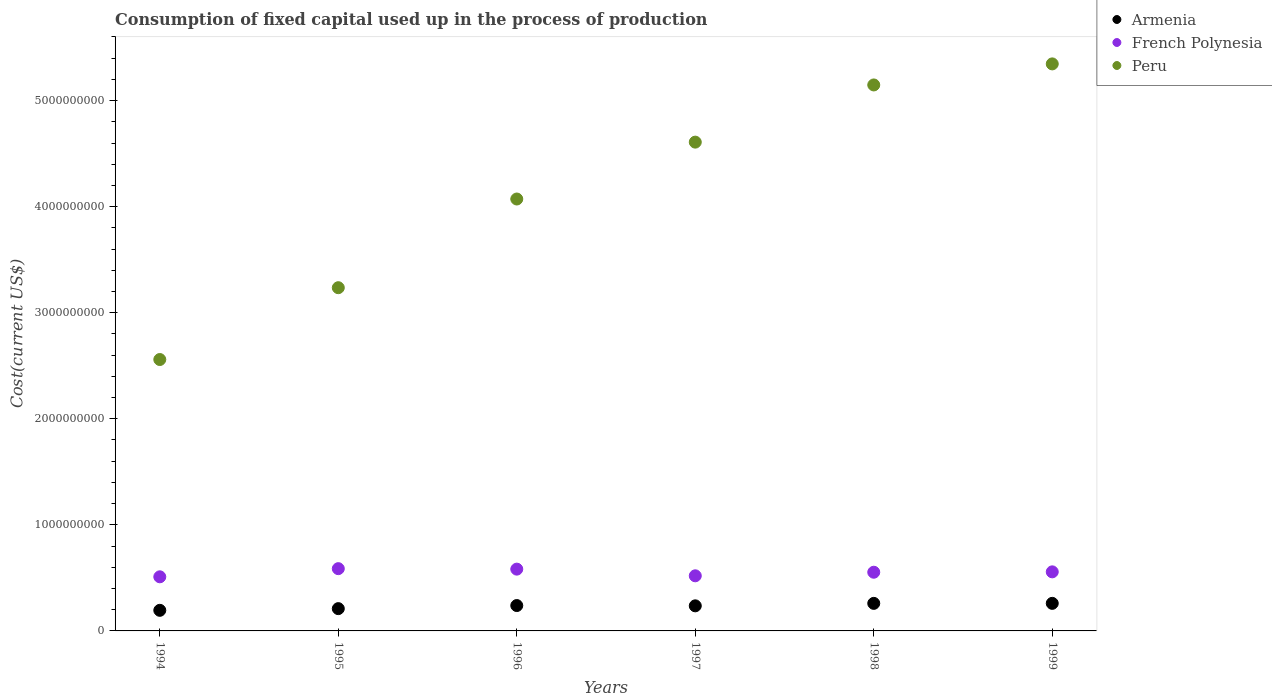How many different coloured dotlines are there?
Your answer should be very brief. 3. Is the number of dotlines equal to the number of legend labels?
Provide a succinct answer. Yes. What is the amount consumed in the process of production in French Polynesia in 1995?
Offer a very short reply. 5.87e+08. Across all years, what is the maximum amount consumed in the process of production in Peru?
Provide a short and direct response. 5.35e+09. Across all years, what is the minimum amount consumed in the process of production in Armenia?
Give a very brief answer. 1.94e+08. In which year was the amount consumed in the process of production in French Polynesia minimum?
Ensure brevity in your answer.  1994. What is the total amount consumed in the process of production in Peru in the graph?
Your answer should be very brief. 2.50e+1. What is the difference between the amount consumed in the process of production in French Polynesia in 1994 and that in 1997?
Your answer should be compact. -9.49e+06. What is the difference between the amount consumed in the process of production in Peru in 1998 and the amount consumed in the process of production in Armenia in 1996?
Offer a very short reply. 4.91e+09. What is the average amount consumed in the process of production in French Polynesia per year?
Provide a succinct answer. 5.52e+08. In the year 1999, what is the difference between the amount consumed in the process of production in Peru and amount consumed in the process of production in French Polynesia?
Make the answer very short. 4.79e+09. In how many years, is the amount consumed in the process of production in French Polynesia greater than 2600000000 US$?
Provide a succinct answer. 0. What is the ratio of the amount consumed in the process of production in Peru in 1996 to that in 1998?
Your answer should be compact. 0.79. What is the difference between the highest and the second highest amount consumed in the process of production in Armenia?
Ensure brevity in your answer.  1.33e+05. What is the difference between the highest and the lowest amount consumed in the process of production in Peru?
Keep it short and to the point. 2.79e+09. Is the amount consumed in the process of production in Peru strictly less than the amount consumed in the process of production in French Polynesia over the years?
Give a very brief answer. No. How many dotlines are there?
Your answer should be very brief. 3. Does the graph contain any zero values?
Your answer should be very brief. No. How many legend labels are there?
Keep it short and to the point. 3. How are the legend labels stacked?
Make the answer very short. Vertical. What is the title of the graph?
Offer a terse response. Consumption of fixed capital used up in the process of production. What is the label or title of the X-axis?
Provide a short and direct response. Years. What is the label or title of the Y-axis?
Your response must be concise. Cost(current US$). What is the Cost(current US$) of Armenia in 1994?
Make the answer very short. 1.94e+08. What is the Cost(current US$) of French Polynesia in 1994?
Your answer should be very brief. 5.10e+08. What is the Cost(current US$) of Peru in 1994?
Make the answer very short. 2.56e+09. What is the Cost(current US$) of Armenia in 1995?
Offer a very short reply. 2.10e+08. What is the Cost(current US$) of French Polynesia in 1995?
Provide a succinct answer. 5.87e+08. What is the Cost(current US$) in Peru in 1995?
Provide a succinct answer. 3.24e+09. What is the Cost(current US$) of Armenia in 1996?
Make the answer very short. 2.39e+08. What is the Cost(current US$) of French Polynesia in 1996?
Offer a very short reply. 5.83e+08. What is the Cost(current US$) in Peru in 1996?
Your answer should be very brief. 4.07e+09. What is the Cost(current US$) in Armenia in 1997?
Offer a very short reply. 2.37e+08. What is the Cost(current US$) of French Polynesia in 1997?
Provide a succinct answer. 5.20e+08. What is the Cost(current US$) of Peru in 1997?
Give a very brief answer. 4.61e+09. What is the Cost(current US$) of Armenia in 1998?
Provide a short and direct response. 2.60e+08. What is the Cost(current US$) in French Polynesia in 1998?
Give a very brief answer. 5.53e+08. What is the Cost(current US$) in Peru in 1998?
Keep it short and to the point. 5.15e+09. What is the Cost(current US$) in Armenia in 1999?
Keep it short and to the point. 2.60e+08. What is the Cost(current US$) in French Polynesia in 1999?
Your answer should be compact. 5.57e+08. What is the Cost(current US$) in Peru in 1999?
Your response must be concise. 5.35e+09. Across all years, what is the maximum Cost(current US$) in Armenia?
Provide a succinct answer. 2.60e+08. Across all years, what is the maximum Cost(current US$) of French Polynesia?
Make the answer very short. 5.87e+08. Across all years, what is the maximum Cost(current US$) in Peru?
Offer a terse response. 5.35e+09. Across all years, what is the minimum Cost(current US$) of Armenia?
Keep it short and to the point. 1.94e+08. Across all years, what is the minimum Cost(current US$) of French Polynesia?
Your response must be concise. 5.10e+08. Across all years, what is the minimum Cost(current US$) of Peru?
Provide a succinct answer. 2.56e+09. What is the total Cost(current US$) of Armenia in the graph?
Your answer should be very brief. 1.40e+09. What is the total Cost(current US$) in French Polynesia in the graph?
Your answer should be very brief. 3.31e+09. What is the total Cost(current US$) in Peru in the graph?
Your response must be concise. 2.50e+1. What is the difference between the Cost(current US$) of Armenia in 1994 and that in 1995?
Offer a very short reply. -1.60e+07. What is the difference between the Cost(current US$) of French Polynesia in 1994 and that in 1995?
Keep it short and to the point. -7.68e+07. What is the difference between the Cost(current US$) in Peru in 1994 and that in 1995?
Provide a short and direct response. -6.77e+08. What is the difference between the Cost(current US$) in Armenia in 1994 and that in 1996?
Give a very brief answer. -4.50e+07. What is the difference between the Cost(current US$) in French Polynesia in 1994 and that in 1996?
Offer a terse response. -7.23e+07. What is the difference between the Cost(current US$) in Peru in 1994 and that in 1996?
Your answer should be compact. -1.51e+09. What is the difference between the Cost(current US$) of Armenia in 1994 and that in 1997?
Offer a terse response. -4.24e+07. What is the difference between the Cost(current US$) in French Polynesia in 1994 and that in 1997?
Keep it short and to the point. -9.49e+06. What is the difference between the Cost(current US$) of Peru in 1994 and that in 1997?
Your answer should be very brief. -2.05e+09. What is the difference between the Cost(current US$) in Armenia in 1994 and that in 1998?
Offer a very short reply. -6.56e+07. What is the difference between the Cost(current US$) in French Polynesia in 1994 and that in 1998?
Provide a succinct answer. -4.31e+07. What is the difference between the Cost(current US$) in Peru in 1994 and that in 1998?
Provide a succinct answer. -2.59e+09. What is the difference between the Cost(current US$) in Armenia in 1994 and that in 1999?
Provide a succinct answer. -6.57e+07. What is the difference between the Cost(current US$) of French Polynesia in 1994 and that in 1999?
Give a very brief answer. -4.67e+07. What is the difference between the Cost(current US$) in Peru in 1994 and that in 1999?
Provide a short and direct response. -2.79e+09. What is the difference between the Cost(current US$) in Armenia in 1995 and that in 1996?
Give a very brief answer. -2.91e+07. What is the difference between the Cost(current US$) in French Polynesia in 1995 and that in 1996?
Give a very brief answer. 4.51e+06. What is the difference between the Cost(current US$) of Peru in 1995 and that in 1996?
Offer a terse response. -8.36e+08. What is the difference between the Cost(current US$) of Armenia in 1995 and that in 1997?
Give a very brief answer. -2.64e+07. What is the difference between the Cost(current US$) in French Polynesia in 1995 and that in 1997?
Your answer should be compact. 6.74e+07. What is the difference between the Cost(current US$) of Peru in 1995 and that in 1997?
Provide a short and direct response. -1.37e+09. What is the difference between the Cost(current US$) of Armenia in 1995 and that in 1998?
Ensure brevity in your answer.  -4.96e+07. What is the difference between the Cost(current US$) of French Polynesia in 1995 and that in 1998?
Provide a succinct answer. 3.37e+07. What is the difference between the Cost(current US$) in Peru in 1995 and that in 1998?
Your response must be concise. -1.91e+09. What is the difference between the Cost(current US$) in Armenia in 1995 and that in 1999?
Offer a terse response. -4.98e+07. What is the difference between the Cost(current US$) of French Polynesia in 1995 and that in 1999?
Provide a succinct answer. 3.01e+07. What is the difference between the Cost(current US$) in Peru in 1995 and that in 1999?
Ensure brevity in your answer.  -2.11e+09. What is the difference between the Cost(current US$) of Armenia in 1996 and that in 1997?
Offer a very short reply. 2.68e+06. What is the difference between the Cost(current US$) in French Polynesia in 1996 and that in 1997?
Your answer should be very brief. 6.28e+07. What is the difference between the Cost(current US$) of Peru in 1996 and that in 1997?
Your response must be concise. -5.36e+08. What is the difference between the Cost(current US$) of Armenia in 1996 and that in 1998?
Offer a terse response. -2.05e+07. What is the difference between the Cost(current US$) in French Polynesia in 1996 and that in 1998?
Offer a very short reply. 2.92e+07. What is the difference between the Cost(current US$) of Peru in 1996 and that in 1998?
Your response must be concise. -1.08e+09. What is the difference between the Cost(current US$) of Armenia in 1996 and that in 1999?
Your answer should be very brief. -2.07e+07. What is the difference between the Cost(current US$) in French Polynesia in 1996 and that in 1999?
Give a very brief answer. 2.56e+07. What is the difference between the Cost(current US$) of Peru in 1996 and that in 1999?
Give a very brief answer. -1.27e+09. What is the difference between the Cost(current US$) of Armenia in 1997 and that in 1998?
Your response must be concise. -2.32e+07. What is the difference between the Cost(current US$) in French Polynesia in 1997 and that in 1998?
Your answer should be very brief. -3.37e+07. What is the difference between the Cost(current US$) of Peru in 1997 and that in 1998?
Give a very brief answer. -5.39e+08. What is the difference between the Cost(current US$) of Armenia in 1997 and that in 1999?
Provide a short and direct response. -2.34e+07. What is the difference between the Cost(current US$) in French Polynesia in 1997 and that in 1999?
Ensure brevity in your answer.  -3.72e+07. What is the difference between the Cost(current US$) in Peru in 1997 and that in 1999?
Your answer should be compact. -7.38e+08. What is the difference between the Cost(current US$) in Armenia in 1998 and that in 1999?
Ensure brevity in your answer.  -1.33e+05. What is the difference between the Cost(current US$) in French Polynesia in 1998 and that in 1999?
Ensure brevity in your answer.  -3.55e+06. What is the difference between the Cost(current US$) in Peru in 1998 and that in 1999?
Keep it short and to the point. -1.98e+08. What is the difference between the Cost(current US$) of Armenia in 1994 and the Cost(current US$) of French Polynesia in 1995?
Make the answer very short. -3.93e+08. What is the difference between the Cost(current US$) in Armenia in 1994 and the Cost(current US$) in Peru in 1995?
Offer a very short reply. -3.04e+09. What is the difference between the Cost(current US$) of French Polynesia in 1994 and the Cost(current US$) of Peru in 1995?
Your answer should be compact. -2.73e+09. What is the difference between the Cost(current US$) of Armenia in 1994 and the Cost(current US$) of French Polynesia in 1996?
Offer a very short reply. -3.88e+08. What is the difference between the Cost(current US$) of Armenia in 1994 and the Cost(current US$) of Peru in 1996?
Give a very brief answer. -3.88e+09. What is the difference between the Cost(current US$) in French Polynesia in 1994 and the Cost(current US$) in Peru in 1996?
Make the answer very short. -3.56e+09. What is the difference between the Cost(current US$) of Armenia in 1994 and the Cost(current US$) of French Polynesia in 1997?
Offer a very short reply. -3.25e+08. What is the difference between the Cost(current US$) in Armenia in 1994 and the Cost(current US$) in Peru in 1997?
Provide a succinct answer. -4.41e+09. What is the difference between the Cost(current US$) of French Polynesia in 1994 and the Cost(current US$) of Peru in 1997?
Your answer should be very brief. -4.10e+09. What is the difference between the Cost(current US$) of Armenia in 1994 and the Cost(current US$) of French Polynesia in 1998?
Provide a succinct answer. -3.59e+08. What is the difference between the Cost(current US$) in Armenia in 1994 and the Cost(current US$) in Peru in 1998?
Keep it short and to the point. -4.95e+09. What is the difference between the Cost(current US$) in French Polynesia in 1994 and the Cost(current US$) in Peru in 1998?
Offer a terse response. -4.64e+09. What is the difference between the Cost(current US$) in Armenia in 1994 and the Cost(current US$) in French Polynesia in 1999?
Keep it short and to the point. -3.63e+08. What is the difference between the Cost(current US$) of Armenia in 1994 and the Cost(current US$) of Peru in 1999?
Give a very brief answer. -5.15e+09. What is the difference between the Cost(current US$) of French Polynesia in 1994 and the Cost(current US$) of Peru in 1999?
Your response must be concise. -4.84e+09. What is the difference between the Cost(current US$) in Armenia in 1995 and the Cost(current US$) in French Polynesia in 1996?
Provide a short and direct response. -3.72e+08. What is the difference between the Cost(current US$) of Armenia in 1995 and the Cost(current US$) of Peru in 1996?
Ensure brevity in your answer.  -3.86e+09. What is the difference between the Cost(current US$) in French Polynesia in 1995 and the Cost(current US$) in Peru in 1996?
Your answer should be very brief. -3.48e+09. What is the difference between the Cost(current US$) in Armenia in 1995 and the Cost(current US$) in French Polynesia in 1997?
Make the answer very short. -3.10e+08. What is the difference between the Cost(current US$) of Armenia in 1995 and the Cost(current US$) of Peru in 1997?
Provide a short and direct response. -4.40e+09. What is the difference between the Cost(current US$) of French Polynesia in 1995 and the Cost(current US$) of Peru in 1997?
Keep it short and to the point. -4.02e+09. What is the difference between the Cost(current US$) in Armenia in 1995 and the Cost(current US$) in French Polynesia in 1998?
Ensure brevity in your answer.  -3.43e+08. What is the difference between the Cost(current US$) of Armenia in 1995 and the Cost(current US$) of Peru in 1998?
Make the answer very short. -4.94e+09. What is the difference between the Cost(current US$) of French Polynesia in 1995 and the Cost(current US$) of Peru in 1998?
Provide a short and direct response. -4.56e+09. What is the difference between the Cost(current US$) in Armenia in 1995 and the Cost(current US$) in French Polynesia in 1999?
Provide a succinct answer. -3.47e+08. What is the difference between the Cost(current US$) of Armenia in 1995 and the Cost(current US$) of Peru in 1999?
Provide a short and direct response. -5.14e+09. What is the difference between the Cost(current US$) in French Polynesia in 1995 and the Cost(current US$) in Peru in 1999?
Keep it short and to the point. -4.76e+09. What is the difference between the Cost(current US$) of Armenia in 1996 and the Cost(current US$) of French Polynesia in 1997?
Make the answer very short. -2.80e+08. What is the difference between the Cost(current US$) in Armenia in 1996 and the Cost(current US$) in Peru in 1997?
Offer a terse response. -4.37e+09. What is the difference between the Cost(current US$) of French Polynesia in 1996 and the Cost(current US$) of Peru in 1997?
Offer a terse response. -4.03e+09. What is the difference between the Cost(current US$) of Armenia in 1996 and the Cost(current US$) of French Polynesia in 1998?
Your response must be concise. -3.14e+08. What is the difference between the Cost(current US$) of Armenia in 1996 and the Cost(current US$) of Peru in 1998?
Provide a short and direct response. -4.91e+09. What is the difference between the Cost(current US$) in French Polynesia in 1996 and the Cost(current US$) in Peru in 1998?
Give a very brief answer. -4.56e+09. What is the difference between the Cost(current US$) in Armenia in 1996 and the Cost(current US$) in French Polynesia in 1999?
Your response must be concise. -3.18e+08. What is the difference between the Cost(current US$) in Armenia in 1996 and the Cost(current US$) in Peru in 1999?
Provide a short and direct response. -5.11e+09. What is the difference between the Cost(current US$) in French Polynesia in 1996 and the Cost(current US$) in Peru in 1999?
Provide a succinct answer. -4.76e+09. What is the difference between the Cost(current US$) in Armenia in 1997 and the Cost(current US$) in French Polynesia in 1998?
Ensure brevity in your answer.  -3.17e+08. What is the difference between the Cost(current US$) in Armenia in 1997 and the Cost(current US$) in Peru in 1998?
Offer a very short reply. -4.91e+09. What is the difference between the Cost(current US$) of French Polynesia in 1997 and the Cost(current US$) of Peru in 1998?
Offer a terse response. -4.63e+09. What is the difference between the Cost(current US$) of Armenia in 1997 and the Cost(current US$) of French Polynesia in 1999?
Ensure brevity in your answer.  -3.20e+08. What is the difference between the Cost(current US$) in Armenia in 1997 and the Cost(current US$) in Peru in 1999?
Offer a very short reply. -5.11e+09. What is the difference between the Cost(current US$) of French Polynesia in 1997 and the Cost(current US$) of Peru in 1999?
Provide a short and direct response. -4.83e+09. What is the difference between the Cost(current US$) in Armenia in 1998 and the Cost(current US$) in French Polynesia in 1999?
Offer a very short reply. -2.97e+08. What is the difference between the Cost(current US$) in Armenia in 1998 and the Cost(current US$) in Peru in 1999?
Ensure brevity in your answer.  -5.09e+09. What is the difference between the Cost(current US$) in French Polynesia in 1998 and the Cost(current US$) in Peru in 1999?
Your response must be concise. -4.79e+09. What is the average Cost(current US$) of Armenia per year?
Provide a succinct answer. 2.33e+08. What is the average Cost(current US$) in French Polynesia per year?
Your answer should be compact. 5.52e+08. What is the average Cost(current US$) of Peru per year?
Ensure brevity in your answer.  4.16e+09. In the year 1994, what is the difference between the Cost(current US$) of Armenia and Cost(current US$) of French Polynesia?
Give a very brief answer. -3.16e+08. In the year 1994, what is the difference between the Cost(current US$) of Armenia and Cost(current US$) of Peru?
Ensure brevity in your answer.  -2.36e+09. In the year 1994, what is the difference between the Cost(current US$) in French Polynesia and Cost(current US$) in Peru?
Your answer should be very brief. -2.05e+09. In the year 1995, what is the difference between the Cost(current US$) in Armenia and Cost(current US$) in French Polynesia?
Ensure brevity in your answer.  -3.77e+08. In the year 1995, what is the difference between the Cost(current US$) in Armenia and Cost(current US$) in Peru?
Provide a short and direct response. -3.03e+09. In the year 1995, what is the difference between the Cost(current US$) of French Polynesia and Cost(current US$) of Peru?
Ensure brevity in your answer.  -2.65e+09. In the year 1996, what is the difference between the Cost(current US$) of Armenia and Cost(current US$) of French Polynesia?
Give a very brief answer. -3.43e+08. In the year 1996, what is the difference between the Cost(current US$) in Armenia and Cost(current US$) in Peru?
Provide a short and direct response. -3.83e+09. In the year 1996, what is the difference between the Cost(current US$) in French Polynesia and Cost(current US$) in Peru?
Offer a terse response. -3.49e+09. In the year 1997, what is the difference between the Cost(current US$) of Armenia and Cost(current US$) of French Polynesia?
Your answer should be very brief. -2.83e+08. In the year 1997, what is the difference between the Cost(current US$) in Armenia and Cost(current US$) in Peru?
Your answer should be very brief. -4.37e+09. In the year 1997, what is the difference between the Cost(current US$) of French Polynesia and Cost(current US$) of Peru?
Offer a terse response. -4.09e+09. In the year 1998, what is the difference between the Cost(current US$) in Armenia and Cost(current US$) in French Polynesia?
Give a very brief answer. -2.94e+08. In the year 1998, what is the difference between the Cost(current US$) in Armenia and Cost(current US$) in Peru?
Give a very brief answer. -4.89e+09. In the year 1998, what is the difference between the Cost(current US$) of French Polynesia and Cost(current US$) of Peru?
Give a very brief answer. -4.59e+09. In the year 1999, what is the difference between the Cost(current US$) of Armenia and Cost(current US$) of French Polynesia?
Your answer should be compact. -2.97e+08. In the year 1999, what is the difference between the Cost(current US$) in Armenia and Cost(current US$) in Peru?
Give a very brief answer. -5.09e+09. In the year 1999, what is the difference between the Cost(current US$) in French Polynesia and Cost(current US$) in Peru?
Provide a succinct answer. -4.79e+09. What is the ratio of the Cost(current US$) of Armenia in 1994 to that in 1995?
Keep it short and to the point. 0.92. What is the ratio of the Cost(current US$) of French Polynesia in 1994 to that in 1995?
Ensure brevity in your answer.  0.87. What is the ratio of the Cost(current US$) in Peru in 1994 to that in 1995?
Provide a succinct answer. 0.79. What is the ratio of the Cost(current US$) of Armenia in 1994 to that in 1996?
Make the answer very short. 0.81. What is the ratio of the Cost(current US$) of French Polynesia in 1994 to that in 1996?
Your answer should be very brief. 0.88. What is the ratio of the Cost(current US$) of Peru in 1994 to that in 1996?
Your response must be concise. 0.63. What is the ratio of the Cost(current US$) of Armenia in 1994 to that in 1997?
Give a very brief answer. 0.82. What is the ratio of the Cost(current US$) of French Polynesia in 1994 to that in 1997?
Ensure brevity in your answer.  0.98. What is the ratio of the Cost(current US$) of Peru in 1994 to that in 1997?
Give a very brief answer. 0.56. What is the ratio of the Cost(current US$) in Armenia in 1994 to that in 1998?
Provide a succinct answer. 0.75. What is the ratio of the Cost(current US$) in French Polynesia in 1994 to that in 1998?
Make the answer very short. 0.92. What is the ratio of the Cost(current US$) in Peru in 1994 to that in 1998?
Provide a succinct answer. 0.5. What is the ratio of the Cost(current US$) of Armenia in 1994 to that in 1999?
Provide a succinct answer. 0.75. What is the ratio of the Cost(current US$) of French Polynesia in 1994 to that in 1999?
Ensure brevity in your answer.  0.92. What is the ratio of the Cost(current US$) in Peru in 1994 to that in 1999?
Offer a very short reply. 0.48. What is the ratio of the Cost(current US$) of Armenia in 1995 to that in 1996?
Ensure brevity in your answer.  0.88. What is the ratio of the Cost(current US$) in French Polynesia in 1995 to that in 1996?
Provide a short and direct response. 1.01. What is the ratio of the Cost(current US$) of Peru in 1995 to that in 1996?
Your response must be concise. 0.79. What is the ratio of the Cost(current US$) in Armenia in 1995 to that in 1997?
Your response must be concise. 0.89. What is the ratio of the Cost(current US$) of French Polynesia in 1995 to that in 1997?
Ensure brevity in your answer.  1.13. What is the ratio of the Cost(current US$) of Peru in 1995 to that in 1997?
Your answer should be very brief. 0.7. What is the ratio of the Cost(current US$) of Armenia in 1995 to that in 1998?
Your answer should be very brief. 0.81. What is the ratio of the Cost(current US$) of French Polynesia in 1995 to that in 1998?
Offer a terse response. 1.06. What is the ratio of the Cost(current US$) in Peru in 1995 to that in 1998?
Your answer should be compact. 0.63. What is the ratio of the Cost(current US$) in Armenia in 1995 to that in 1999?
Your answer should be very brief. 0.81. What is the ratio of the Cost(current US$) of French Polynesia in 1995 to that in 1999?
Offer a terse response. 1.05. What is the ratio of the Cost(current US$) in Peru in 1995 to that in 1999?
Offer a very short reply. 0.61. What is the ratio of the Cost(current US$) of Armenia in 1996 to that in 1997?
Your answer should be compact. 1.01. What is the ratio of the Cost(current US$) of French Polynesia in 1996 to that in 1997?
Give a very brief answer. 1.12. What is the ratio of the Cost(current US$) in Peru in 1996 to that in 1997?
Your response must be concise. 0.88. What is the ratio of the Cost(current US$) of Armenia in 1996 to that in 1998?
Ensure brevity in your answer.  0.92. What is the ratio of the Cost(current US$) of French Polynesia in 1996 to that in 1998?
Provide a succinct answer. 1.05. What is the ratio of the Cost(current US$) in Peru in 1996 to that in 1998?
Your answer should be compact. 0.79. What is the ratio of the Cost(current US$) in Armenia in 1996 to that in 1999?
Your answer should be compact. 0.92. What is the ratio of the Cost(current US$) in French Polynesia in 1996 to that in 1999?
Ensure brevity in your answer.  1.05. What is the ratio of the Cost(current US$) of Peru in 1996 to that in 1999?
Offer a very short reply. 0.76. What is the ratio of the Cost(current US$) in Armenia in 1997 to that in 1998?
Your answer should be compact. 0.91. What is the ratio of the Cost(current US$) of French Polynesia in 1997 to that in 1998?
Your answer should be very brief. 0.94. What is the ratio of the Cost(current US$) of Peru in 1997 to that in 1998?
Offer a terse response. 0.9. What is the ratio of the Cost(current US$) in Armenia in 1997 to that in 1999?
Make the answer very short. 0.91. What is the ratio of the Cost(current US$) in French Polynesia in 1997 to that in 1999?
Ensure brevity in your answer.  0.93. What is the ratio of the Cost(current US$) of Peru in 1997 to that in 1999?
Offer a terse response. 0.86. What is the ratio of the Cost(current US$) of French Polynesia in 1998 to that in 1999?
Your answer should be compact. 0.99. What is the ratio of the Cost(current US$) of Peru in 1998 to that in 1999?
Your answer should be very brief. 0.96. What is the difference between the highest and the second highest Cost(current US$) in Armenia?
Your response must be concise. 1.33e+05. What is the difference between the highest and the second highest Cost(current US$) of French Polynesia?
Ensure brevity in your answer.  4.51e+06. What is the difference between the highest and the second highest Cost(current US$) in Peru?
Keep it short and to the point. 1.98e+08. What is the difference between the highest and the lowest Cost(current US$) in Armenia?
Ensure brevity in your answer.  6.57e+07. What is the difference between the highest and the lowest Cost(current US$) in French Polynesia?
Make the answer very short. 7.68e+07. What is the difference between the highest and the lowest Cost(current US$) of Peru?
Provide a short and direct response. 2.79e+09. 